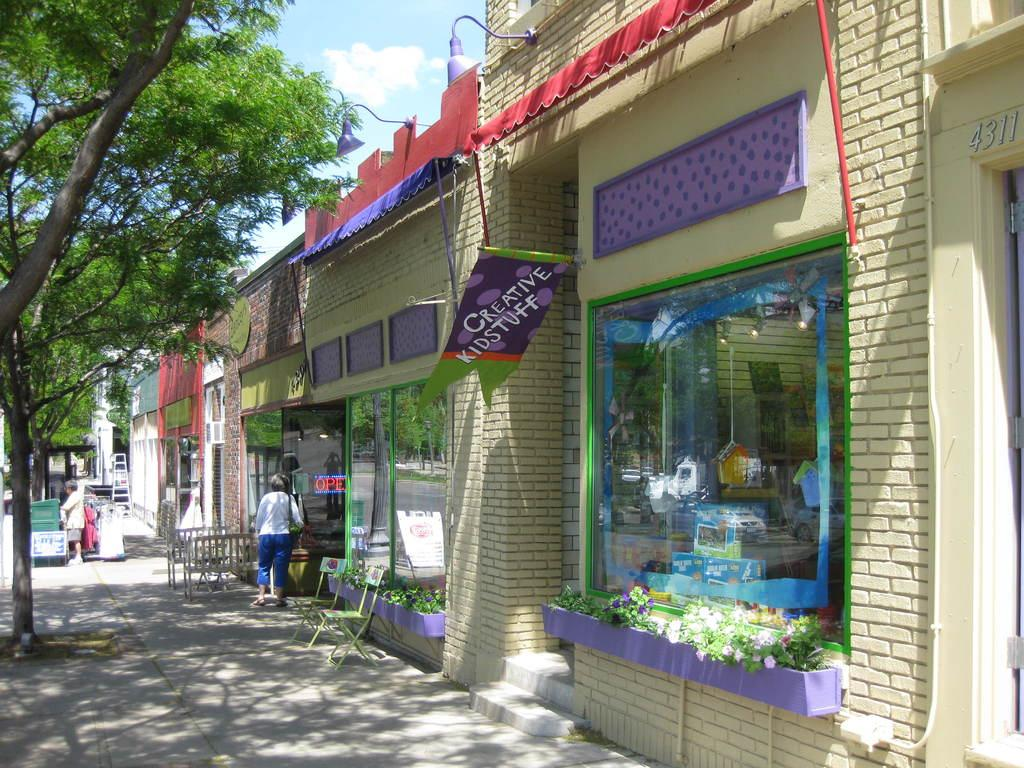What type of structure is present in the image? There is a building in the image. What type of seating is available in the image? There are chairs and benches in the image. Are there any people in the image? Yes, there are persons in the image. What is the purpose of the ladder in the image? The ladder's purpose is not clear from the image, but it might be used for reaching higher areas. What type of vegetation is present in the image? There are trees and plants in the image. What can be seen in the sky in the image? The sky is visible in the image, and there are clouds present. How many bedrooms are visible in the image? There is no bedroom present in the image. What type of drop can be seen falling from the sky in the image? There is no drop falling from the sky in the image. 